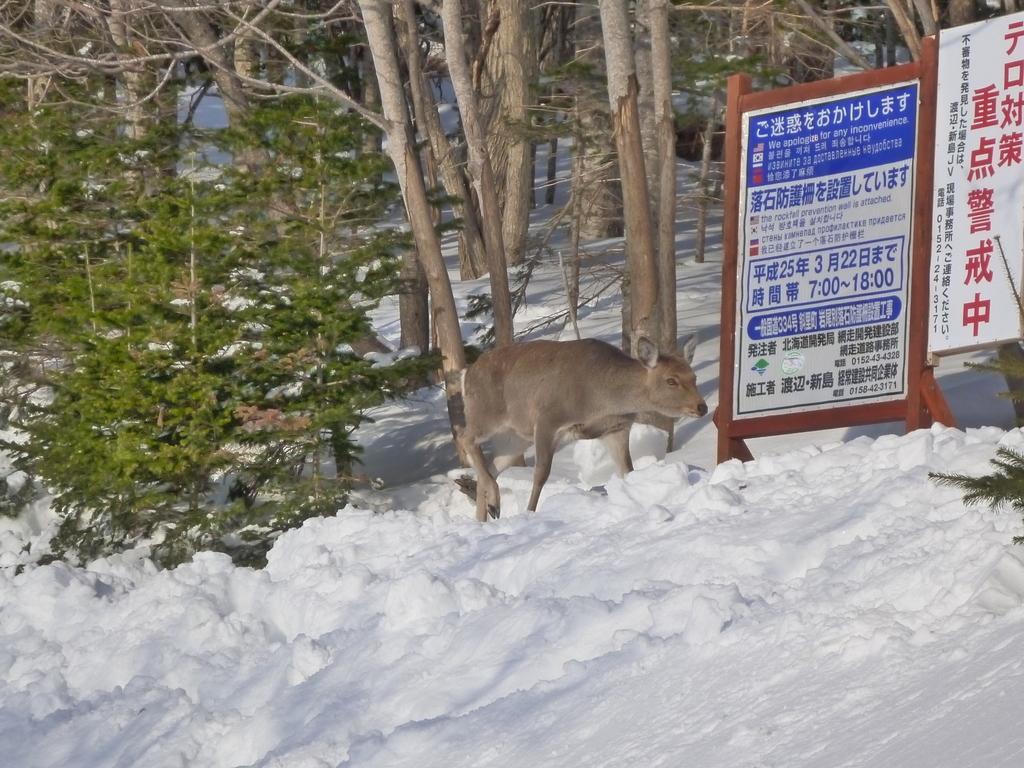Describe this image in one or two sentences. In this image I can see an animal and I can see trees, plants , boats and on boats I can see text. 